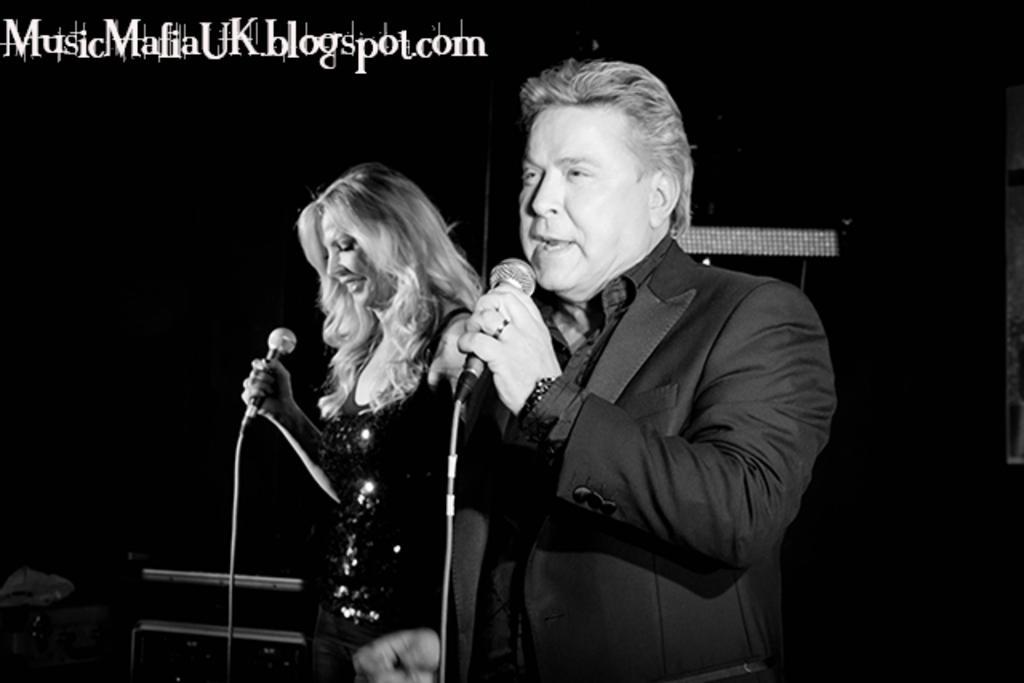Please provide a concise description of this image. There is man with black jacket in the right side is holding a mic in his left hand. And to the left side there is a lady with the black dress. She is holding a mic in her right hand. The man is singing. 